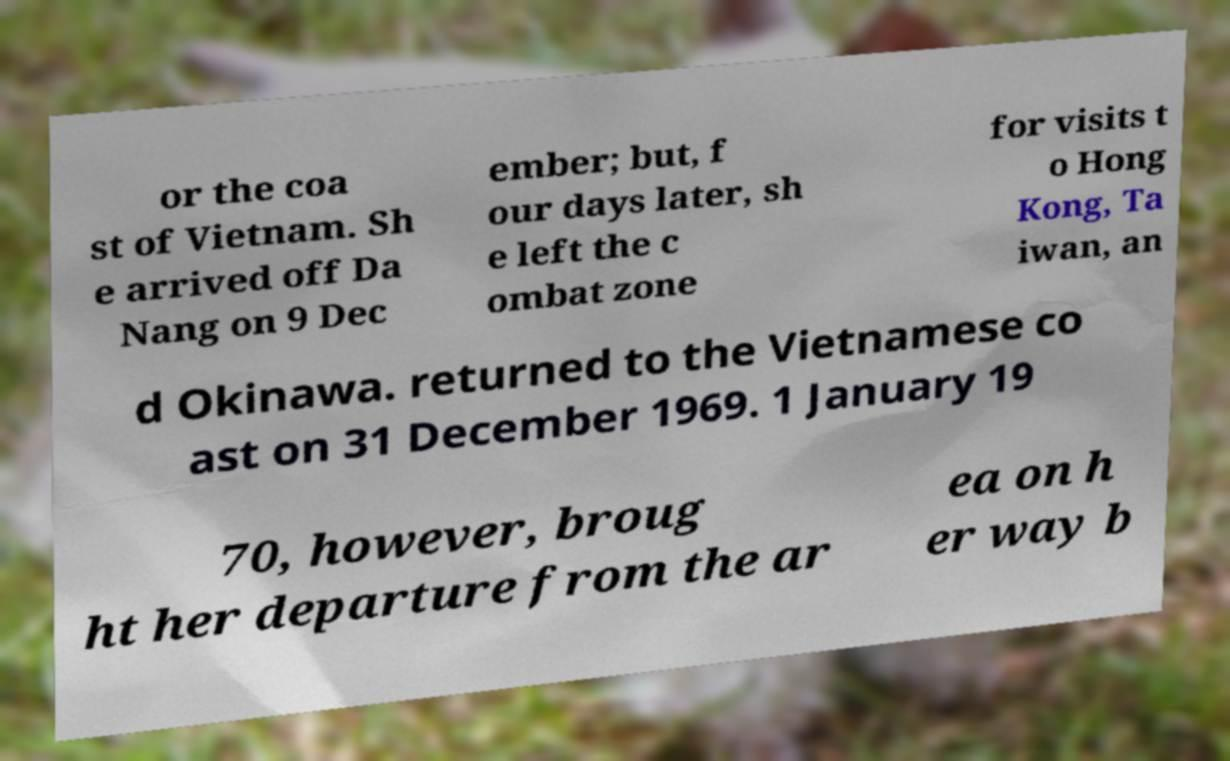For documentation purposes, I need the text within this image transcribed. Could you provide that? or the coa st of Vietnam. Sh e arrived off Da Nang on 9 Dec ember; but, f our days later, sh e left the c ombat zone for visits t o Hong Kong, Ta iwan, an d Okinawa. returned to the Vietnamese co ast on 31 December 1969. 1 January 19 70, however, broug ht her departure from the ar ea on h er way b 